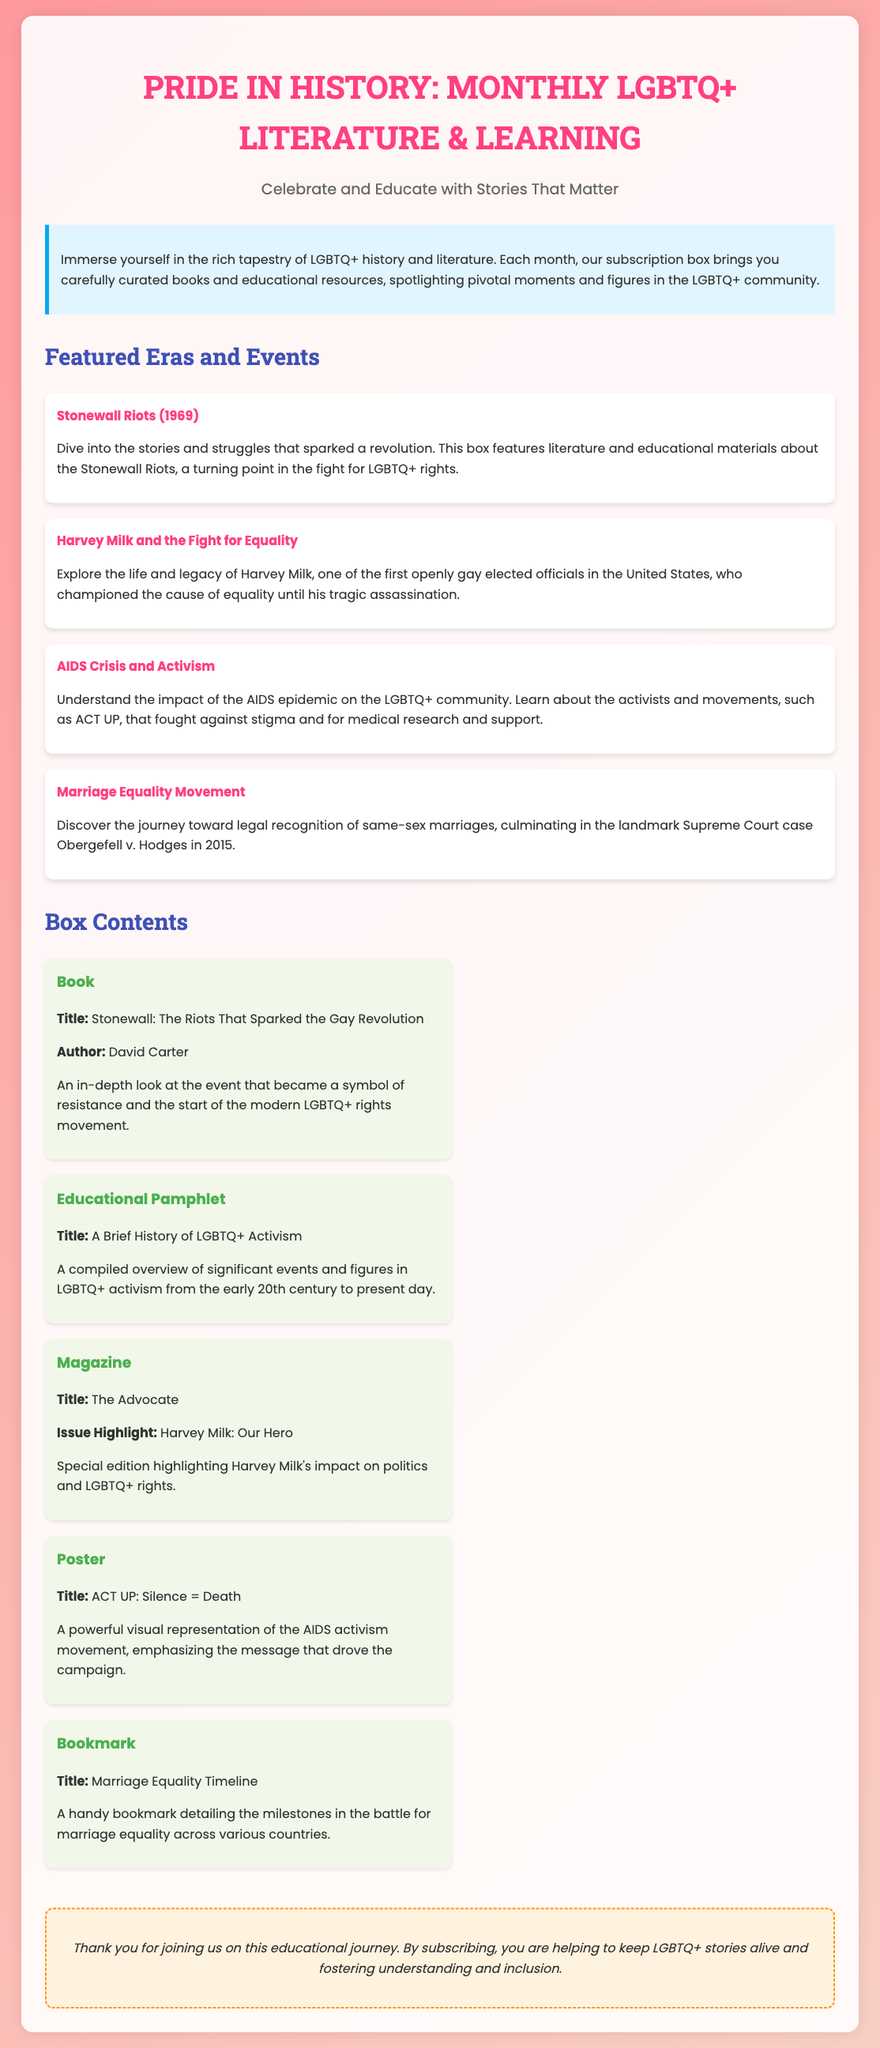what is the title of the subscription box service? The title of the subscription box service is highlighted at the top of the document.
Answer: PRIDE IN HISTORY: MONTHLY LGBTQ+ LITERATURE & LEARNING how often are the boxes delivered? The frequency of the box deliveries is stated in the introductory description.
Answer: monthly what event is featured in the March box? The featured event for a particular month is implied in the document, relating to LGBTQ+ history.
Answer: Stonewall Riots (1969) who is the author of the book included in the box? The author of the book is specified under the book details in the box contents section.
Answer: David Carter what kind of materials are included in the subscription box? The types of materials included can be found in the contents list section of the document.
Answer: books and educational resources what is emphasized in the ACT UP poster? The content of the poster is described in the relevant content item section.
Answer: Silence = Death which landmark case relates to marriage equality? The document mentions a significant case in the context of marriage equality.
Answer: Obergefell v. Hodges what is the customer note about? The customer note provides information on the purpose of the subscription and appreciation for subscribers.
Answer: Thank you for joining us on this educational journey 